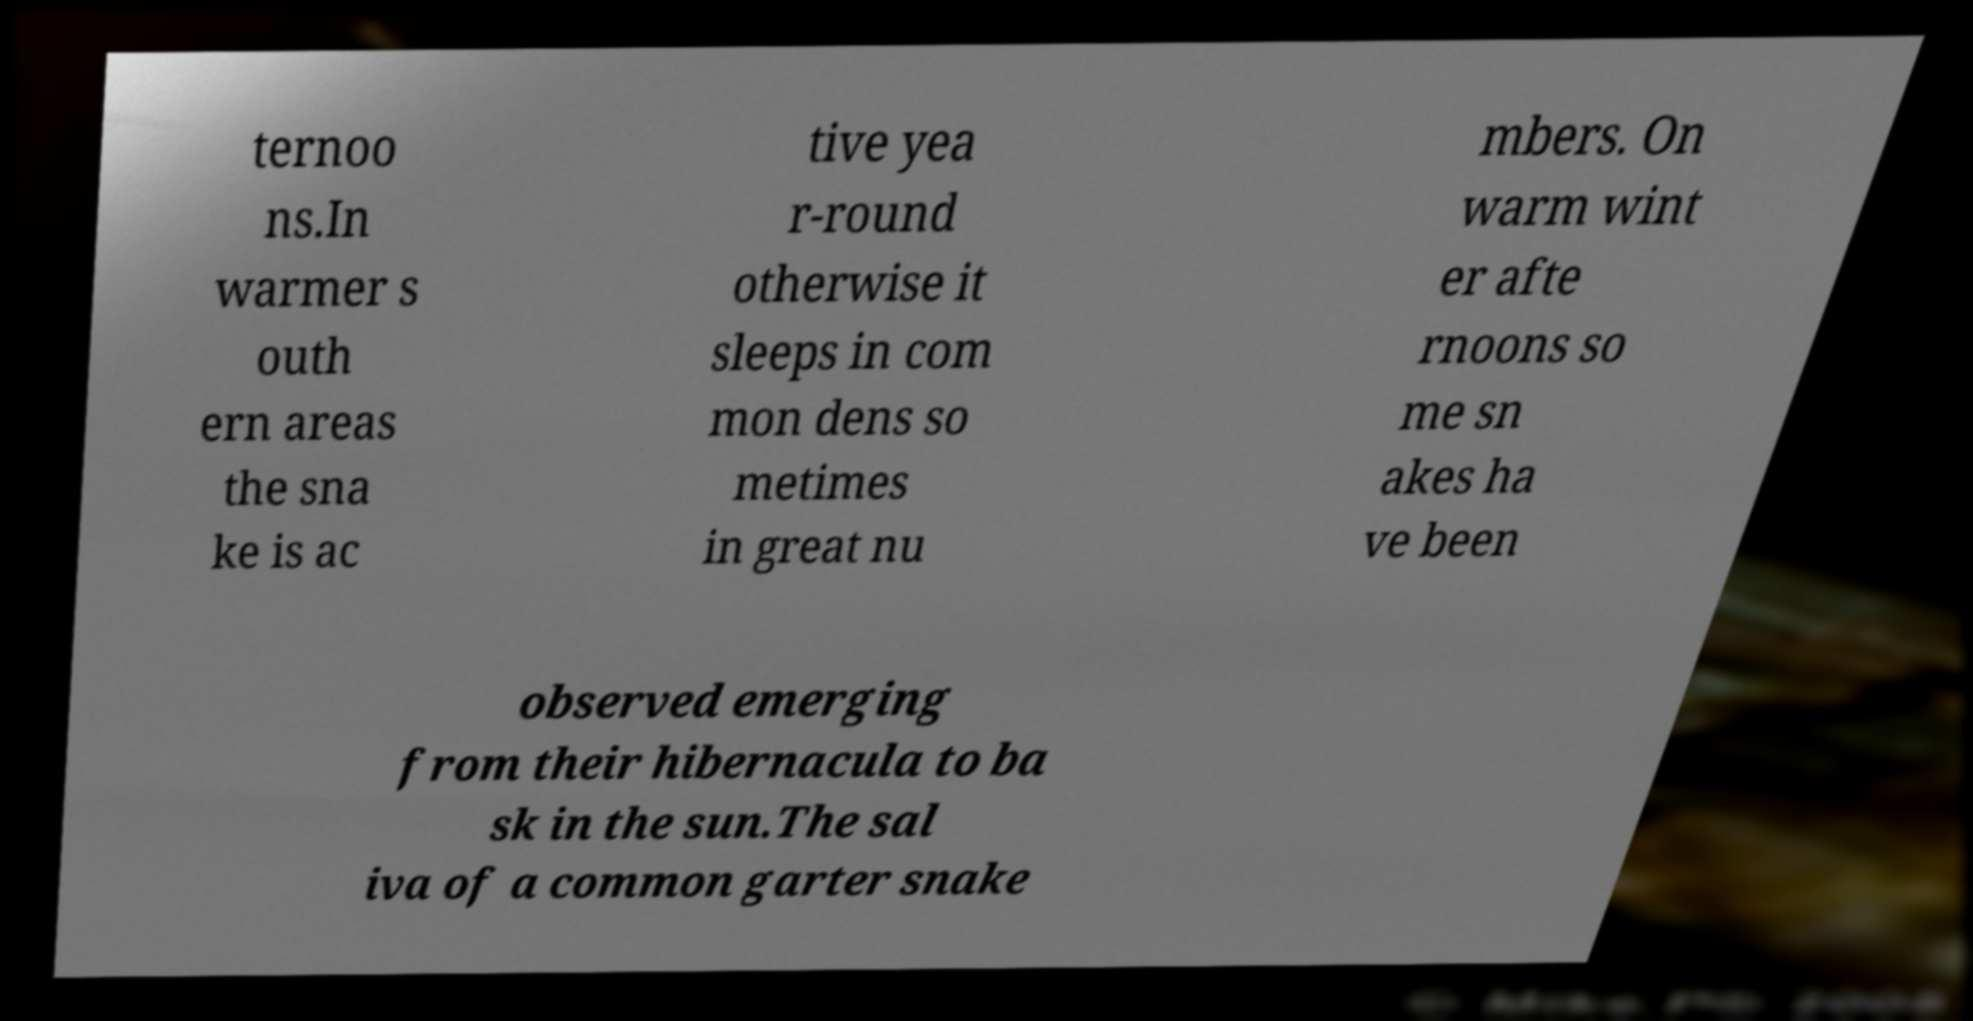I need the written content from this picture converted into text. Can you do that? ternoo ns.In warmer s outh ern areas the sna ke is ac tive yea r-round otherwise it sleeps in com mon dens so metimes in great nu mbers. On warm wint er afte rnoons so me sn akes ha ve been observed emerging from their hibernacula to ba sk in the sun.The sal iva of a common garter snake 